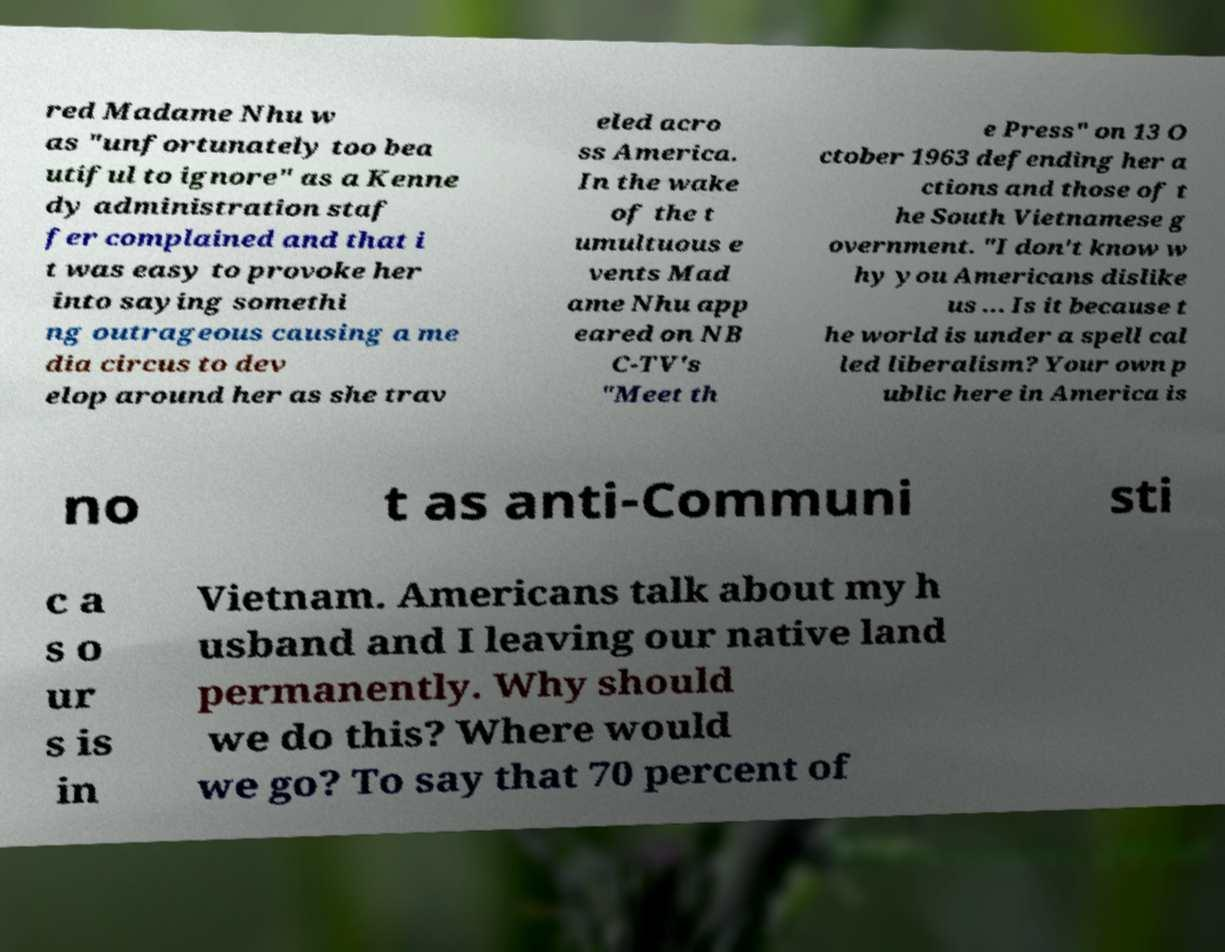Could you assist in decoding the text presented in this image and type it out clearly? red Madame Nhu w as "unfortunately too bea utiful to ignore" as a Kenne dy administration staf fer complained and that i t was easy to provoke her into saying somethi ng outrageous causing a me dia circus to dev elop around her as she trav eled acro ss America. In the wake of the t umultuous e vents Mad ame Nhu app eared on NB C-TV's "Meet th e Press" on 13 O ctober 1963 defending her a ctions and those of t he South Vietnamese g overnment. "I don't know w hy you Americans dislike us ... Is it because t he world is under a spell cal led liberalism? Your own p ublic here in America is no t as anti-Communi sti c a s o ur s is in Vietnam. Americans talk about my h usband and I leaving our native land permanently. Why should we do this? Where would we go? To say that 70 percent of 